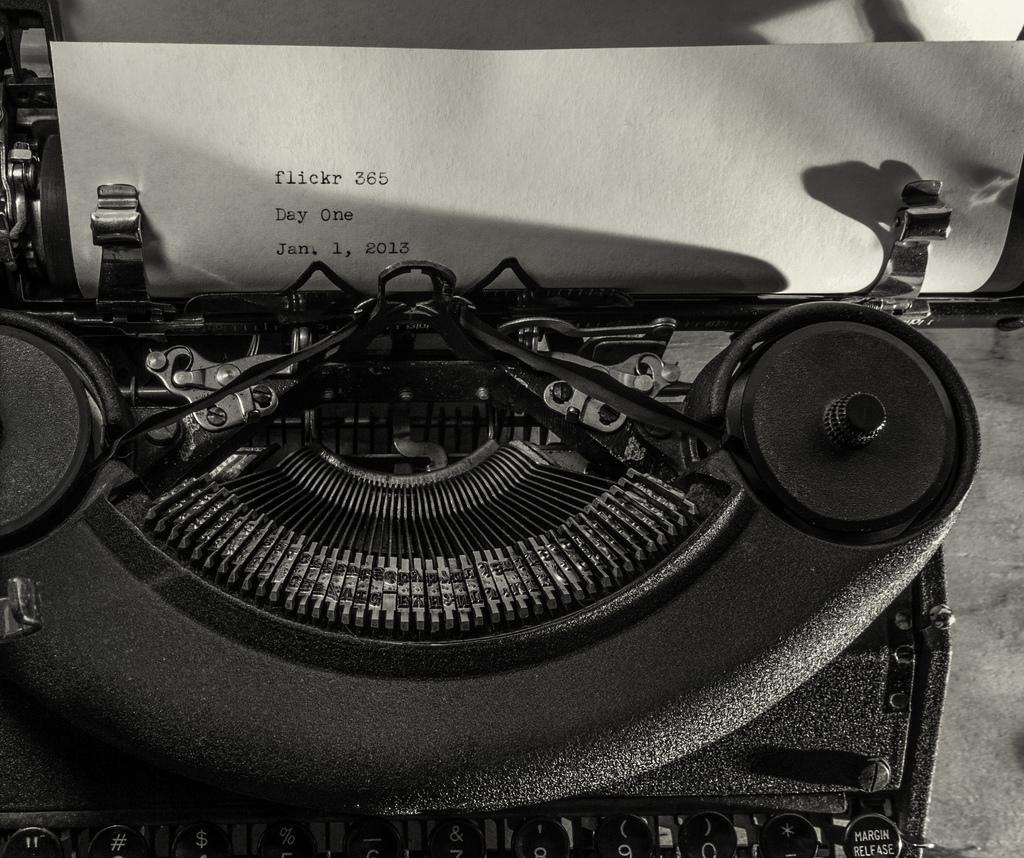What is the main object in the image? There is a typing machine in the image. What is the typing machine being used for? The typing machine is being used to create text on a paper, as there is text visible on a paper in the image. Can you see a frog with a tail in the image? There is no frog or tail present in the image; it features a typing machine and text on a paper. 